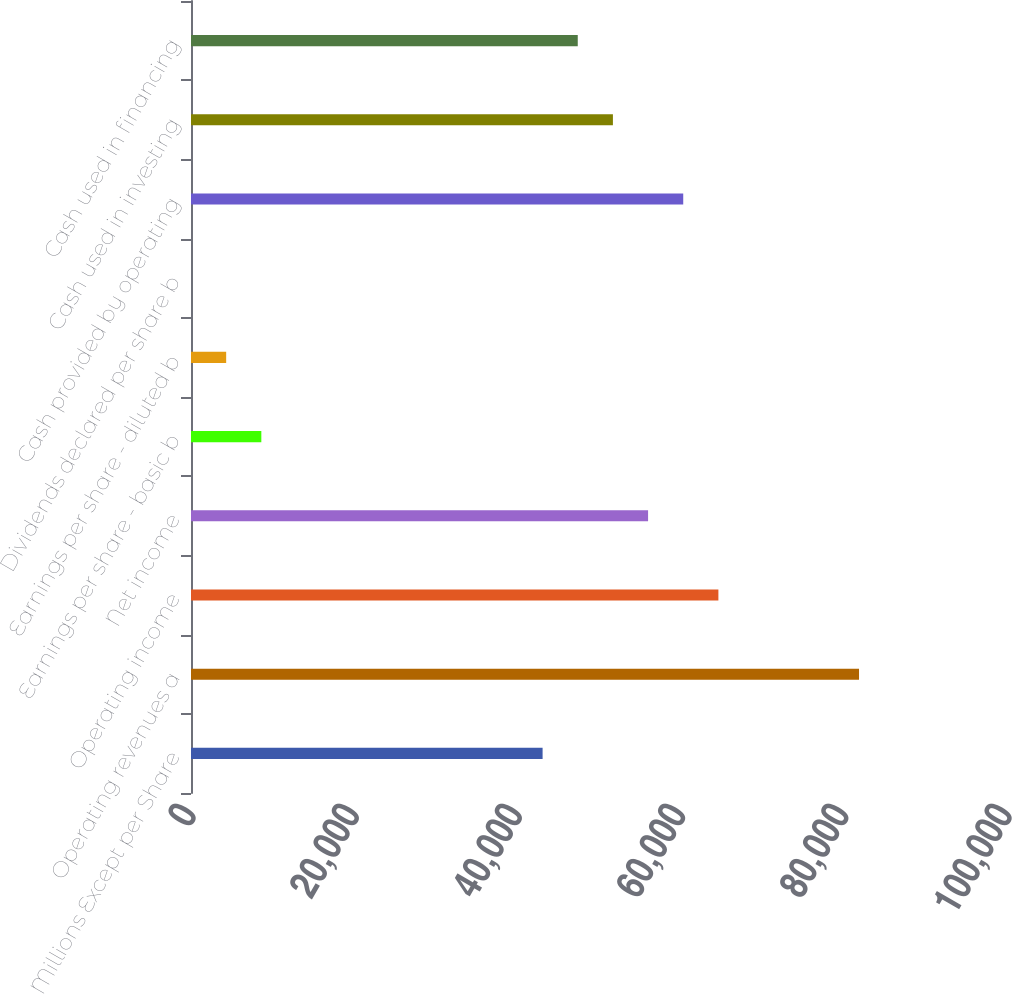Convert chart to OTSL. <chart><loc_0><loc_0><loc_500><loc_500><bar_chart><fcel>Millions Except per Share<fcel>Operating revenues a<fcel>Operating income<fcel>Net income<fcel>Earnings per share - basic b<fcel>Earnings per share - diluted b<fcel>Dividends declared per share b<fcel>Cash provided by operating<fcel>Cash used in investing<fcel>Cash used in financing<nl><fcel>43088<fcel>81866<fcel>64631.4<fcel>56014<fcel>8618.65<fcel>4309.98<fcel>1.31<fcel>60322.7<fcel>51705.3<fcel>47396.7<nl></chart> 